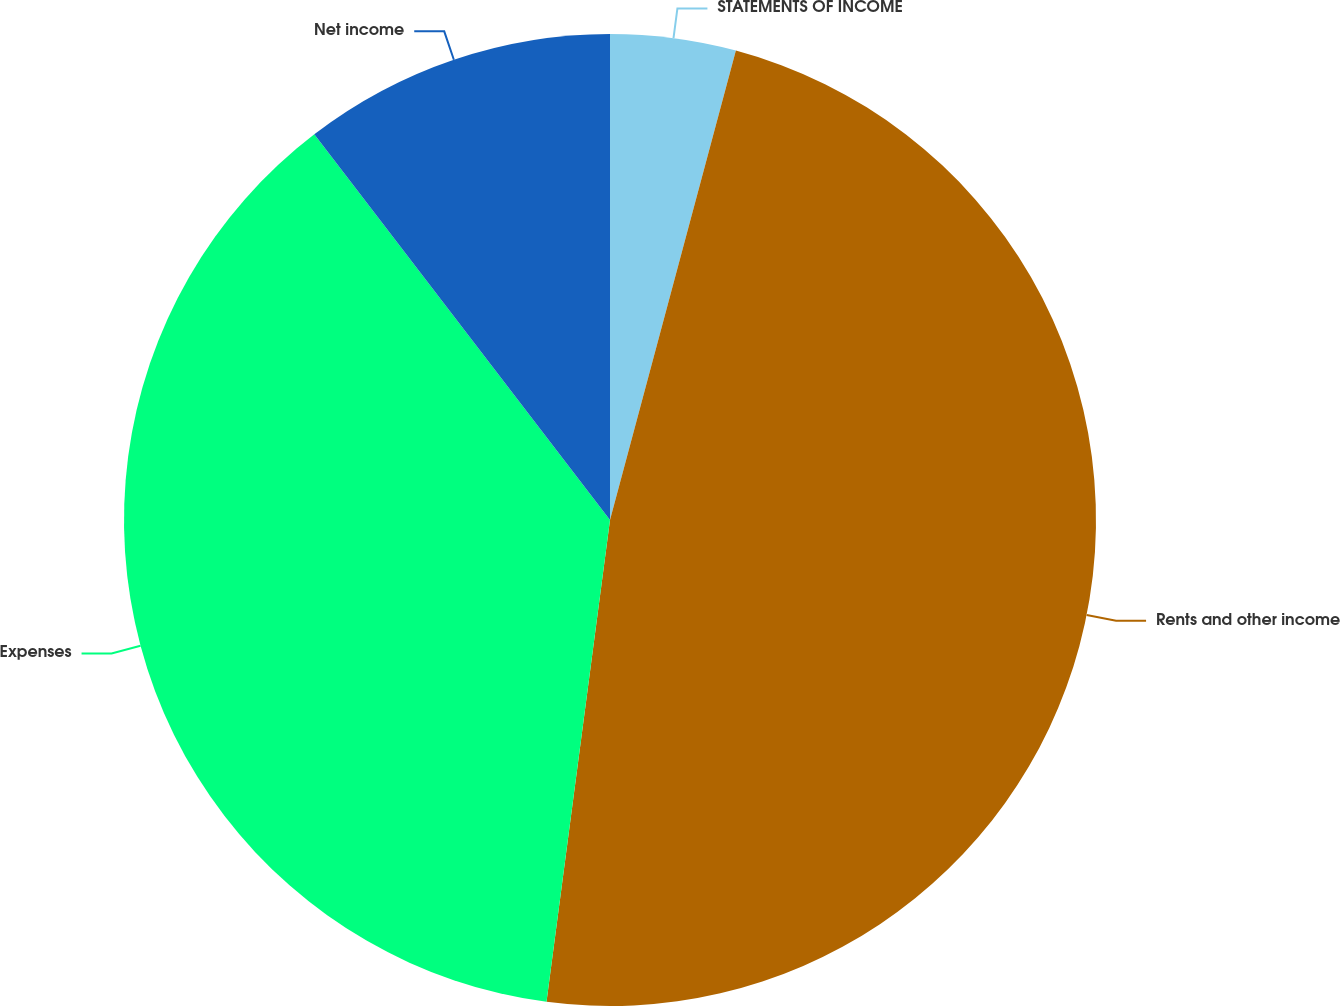Convert chart. <chart><loc_0><loc_0><loc_500><loc_500><pie_chart><fcel>STATEMENTS OF INCOME<fcel>Rents and other income<fcel>Expenses<fcel>Net income<nl><fcel>4.17%<fcel>47.91%<fcel>37.5%<fcel>10.41%<nl></chart> 